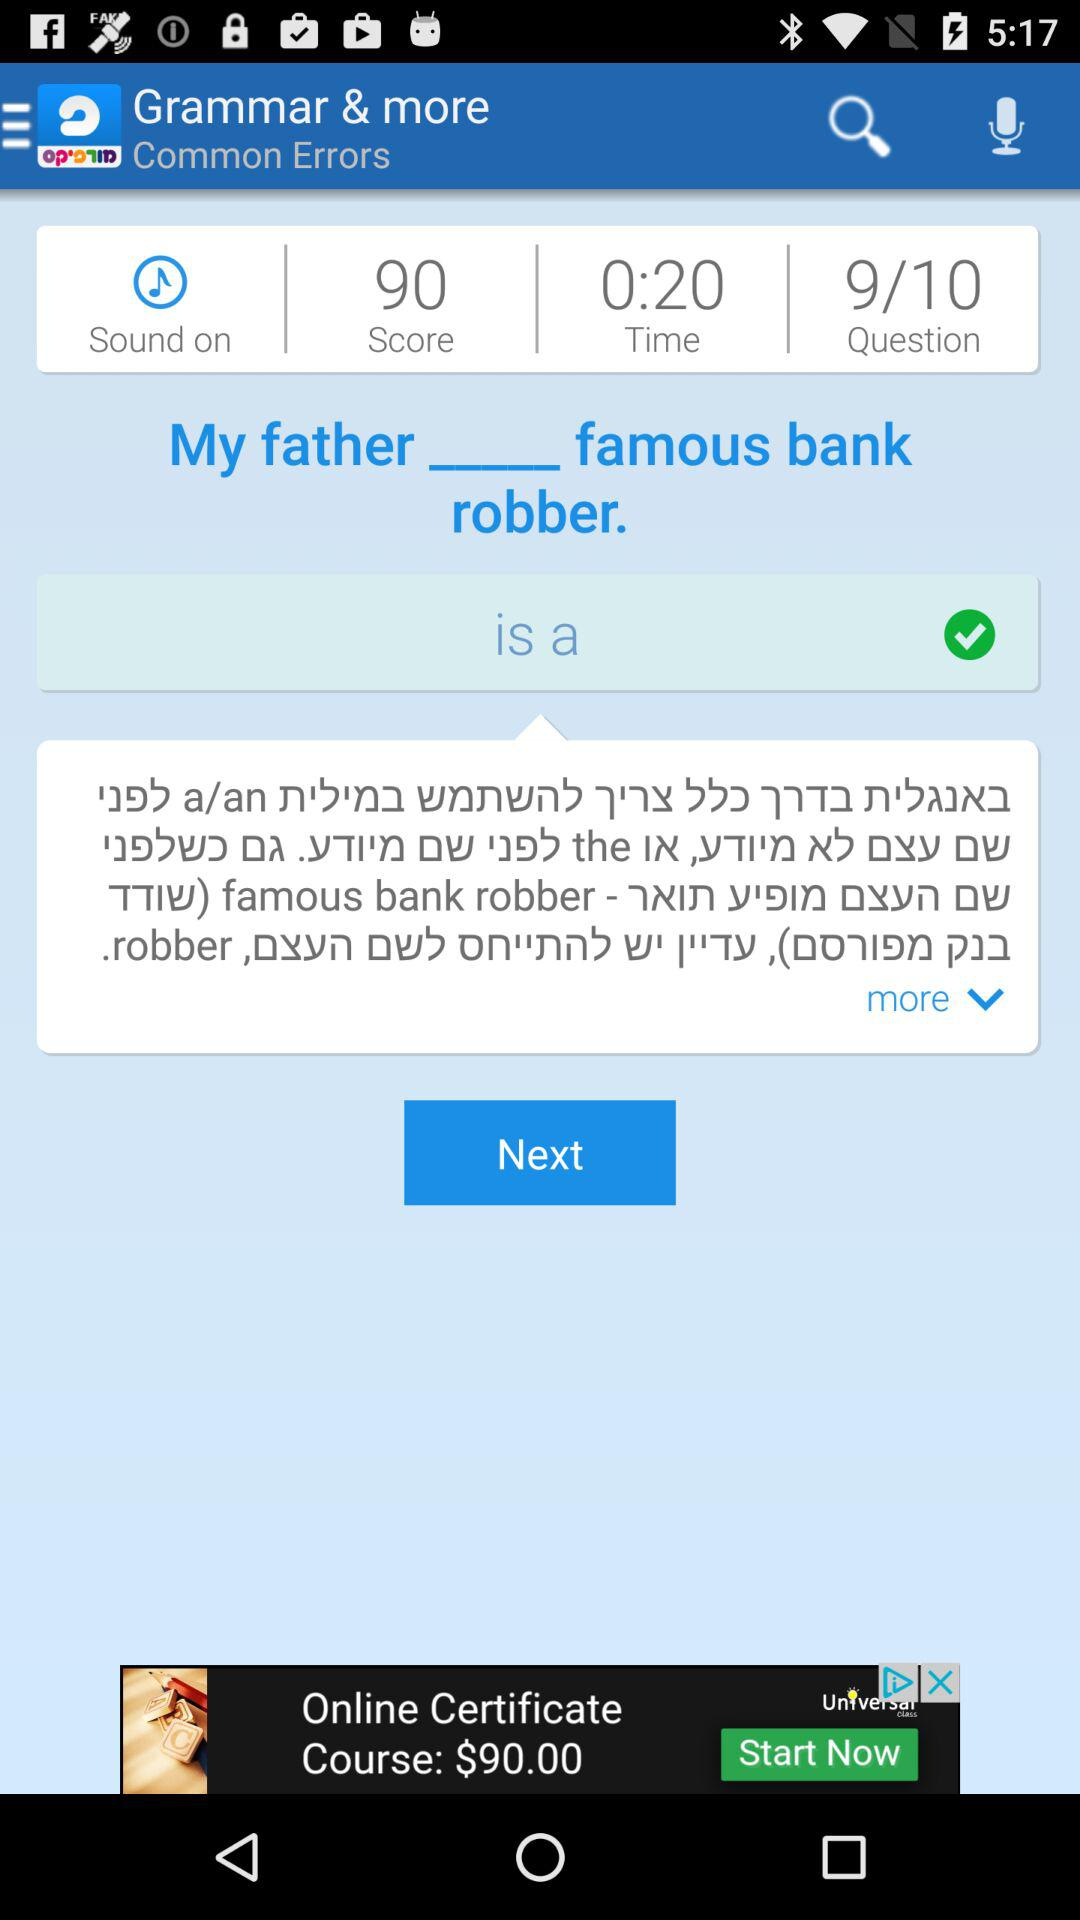On which question am I? You are on the ninth question. 